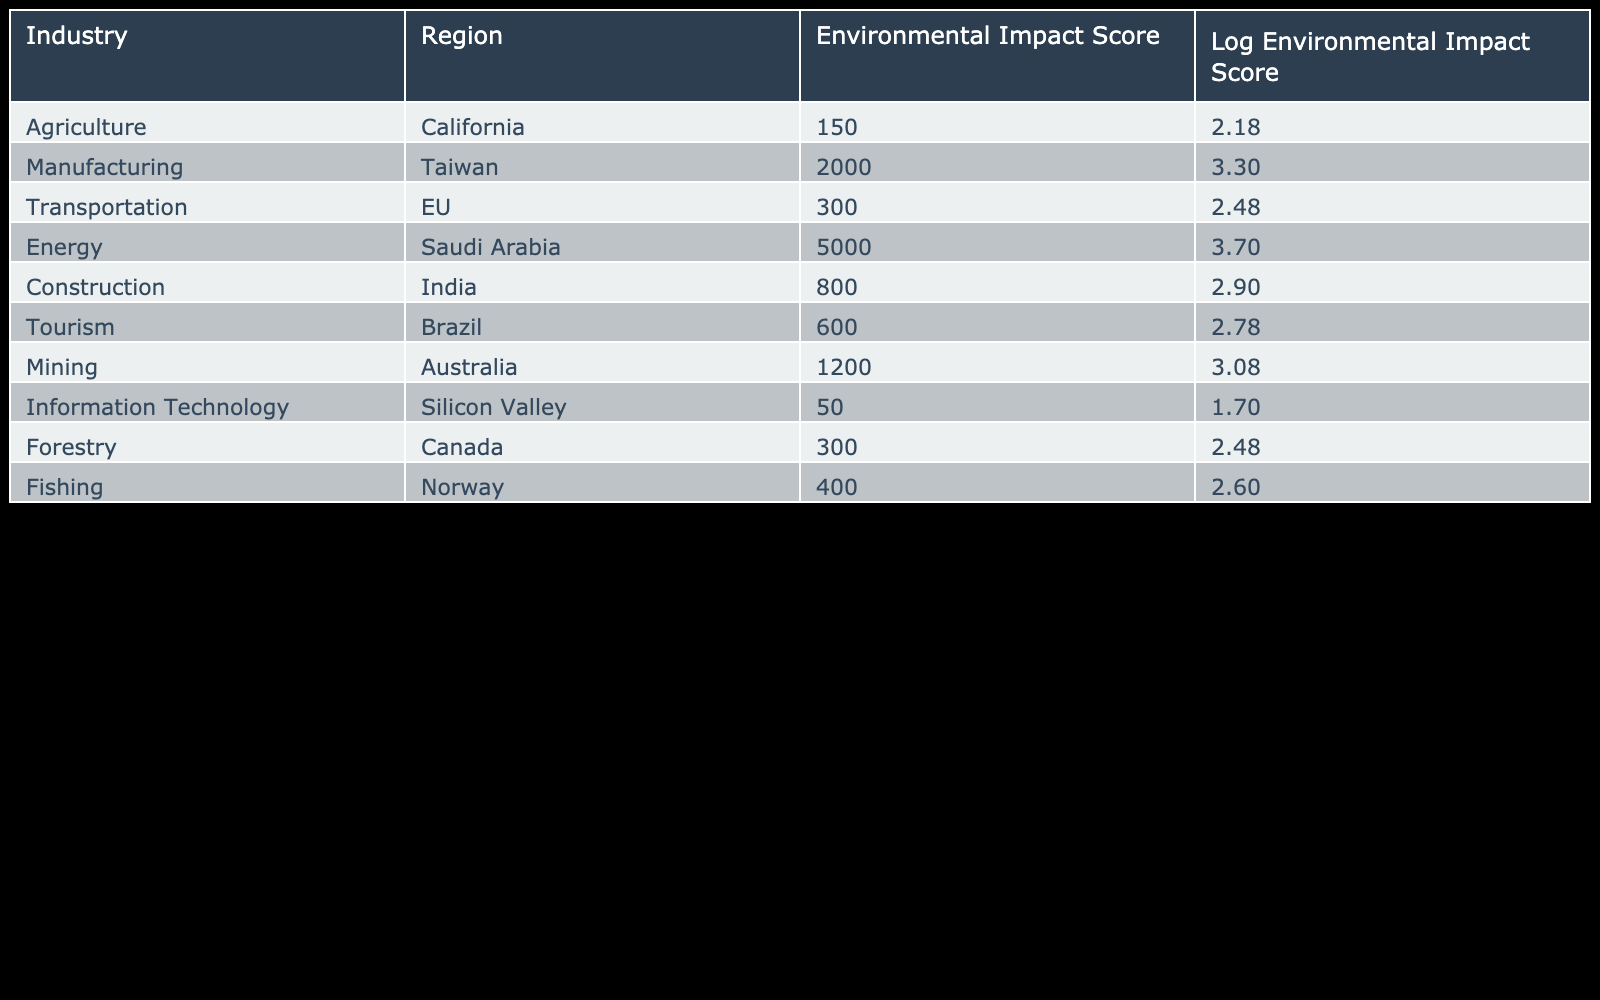What is the Environmental Impact Score for the Energy industry in Saudi Arabia? From the table, we can directly refer to the row for the Energy industry in Saudi Arabia, which shows an Environmental Impact Score of 5000.
Answer: 5000 Which industry has the lowest Environmental Impact Score? By comparing the Environmental Impact Scores from the table, the Information Technology industry in Silicon Valley has the lowest score of 50.
Answer: 50 What is the average Environmental Impact Score across all regions? To find the average, we add up all the Environmental Impact Scores: 150 + 2000 + 300 + 5000 + 800 + 600 + 1200 + 50 + 300 + 400 = 7000. Then, we divide by the number of industries, which is 10: 7000/10 = 700.
Answer: 700 Is the Environmental Impact Score for Transportation in the EU greater than that of Agriculture in California? The score for Transportation in the EU is 300, while for Agriculture in California it is 150. Since 300 is greater than 150, the statement is true.
Answer: Yes Which region has the highest Environmental Impact Score, and what is it? A comparison of the scores reveals that the Energy industry in Saudi Arabia has the highest score of 5000.
Answer: Saudi Arabia, 5000 What is the difference in Environmental Impact Scores between the Manufacturing industry in Taiwan and the Mining industry in Australia? The Manufacturing industry in Taiwan has a score of 2000, while the Mining industry in Australia has a score of 1200. We subtract the two scores: 2000 - 1200 = 800.
Answer: 800 Are there any industries in regions with Environmental Impact Scores below 100? Reviewing the table shows that the lowest Environmental Impact Score is 50 for the Information Technology industry, which is indeed below 100, answering the query as true.
Answer: Yes What is the combined Environmental Impact Score for all industries related to natural resources (Agriculture, Forestry, Fishing, and Mining)? First, we find the scores: Agriculture = 150, Forestry = 300, Fishing = 400, Mining = 1200. Adding them gives: 150 + 300 + 400 + 1200 = 2050, representing the combined score.
Answer: 2050 